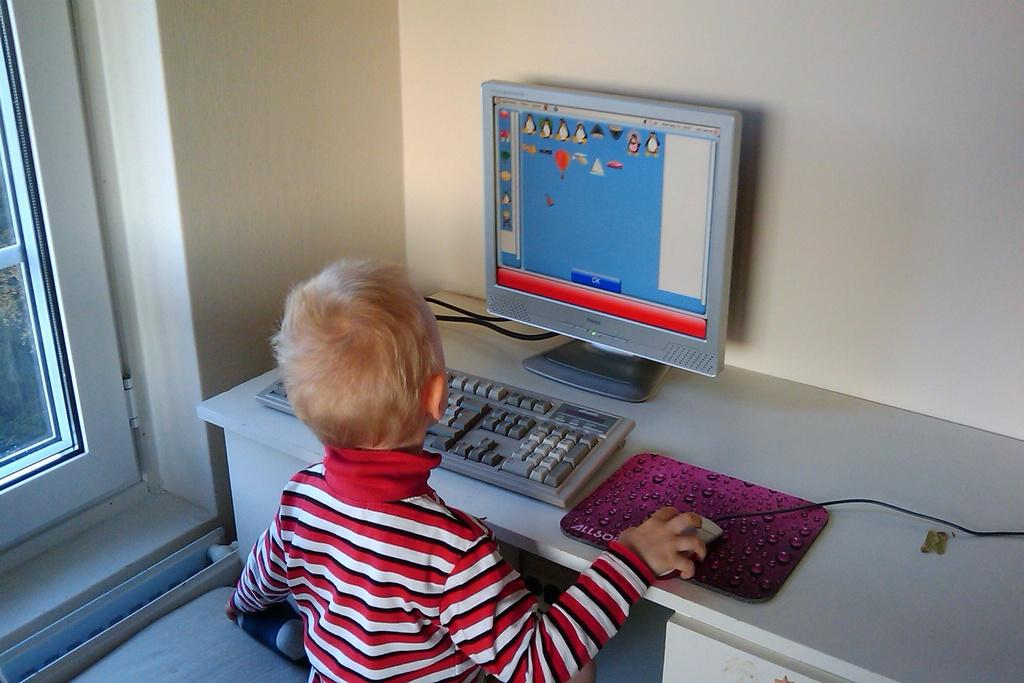What is the main subject of the image? The main subject of the image is a small boy. What is the boy doing in the image? The boy is operating a system in the image. Where is the system located in relation to the boy? The system is on a table in front of the boy. What type of beast can be seen interacting with the boy in the image? There is no beast present in the image; it only features a small boy operating a system on a table. 